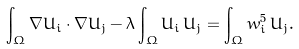<formula> <loc_0><loc_0><loc_500><loc_500>\int _ { \Omega } \nabla U _ { i } \cdot \nabla U _ { j } - \lambda \int _ { \Omega } U _ { i } \, U _ { j } = \int _ { \Omega } w _ { i } ^ { 5 } \, U _ { j } .</formula> 